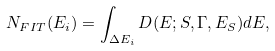<formula> <loc_0><loc_0><loc_500><loc_500>N _ { F I T } ( E _ { i } ) = \int _ { \Delta E _ { i } } D ( E ; S , \Gamma , E _ { S } ) d E ,</formula> 